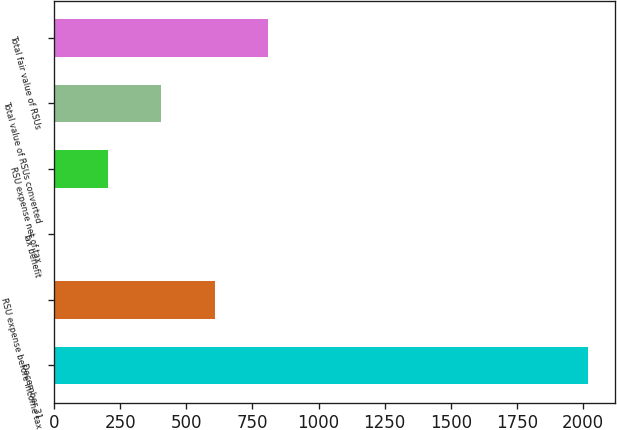Convert chart. <chart><loc_0><loc_0><loc_500><loc_500><bar_chart><fcel>December 31<fcel>RSU expense before income tax<fcel>Tax benefit<fcel>RSU expense net of tax<fcel>Total value of RSUs converted<fcel>Total fair value of RSUs<nl><fcel>2018<fcel>606.8<fcel>2<fcel>203.6<fcel>405.2<fcel>808.4<nl></chart> 